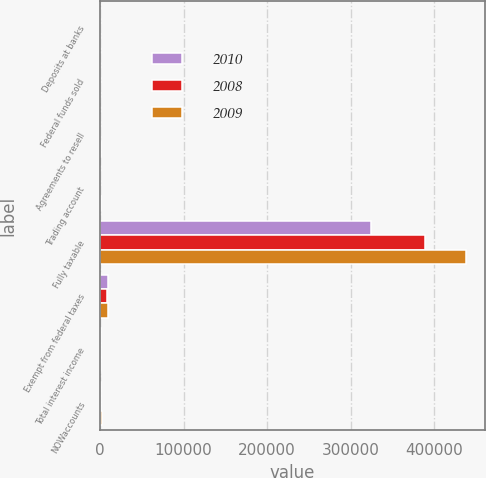Convert chart to OTSL. <chart><loc_0><loc_0><loc_500><loc_500><stacked_bar_chart><ecel><fcel>Deposits at banks<fcel>Federal funds sold<fcel>Agreements to resell<fcel>Trading account<fcel>Fully taxable<fcel>Exempt from federal taxes<fcel>Total interest income<fcel>NOWaccounts<nl><fcel>2010<fcel>88<fcel>42<fcel>404<fcel>615<fcel>324695<fcel>9869<fcel>850<fcel>850<nl><fcel>2008<fcel>34<fcel>63<fcel>66<fcel>534<fcel>389268<fcel>8484<fcel>850<fcel>1122<nl><fcel>2009<fcel>109<fcel>254<fcel>1817<fcel>1469<fcel>438409<fcel>9946<fcel>850<fcel>2894<nl></chart> 